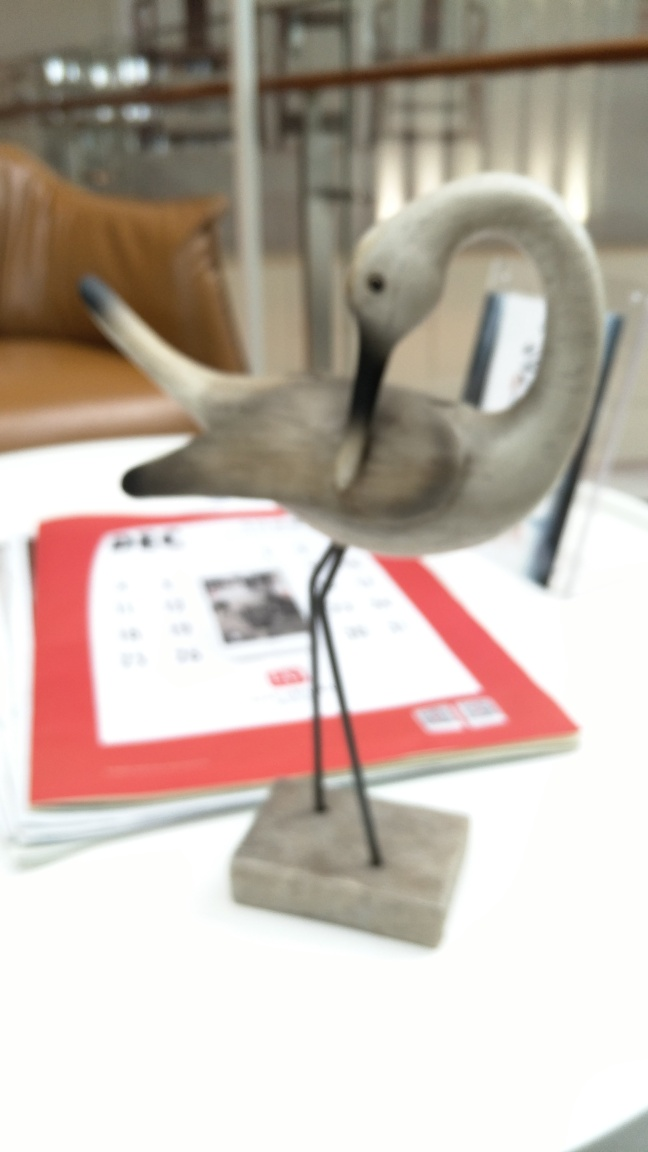Can you tell if this object has any functional purpose? From the image, it appears that this crane is a decorative piece, rather than a functional item. It's placed atop what could be a calendar or a book, suggesting that it's likely used as an ornament or a paperweight. 